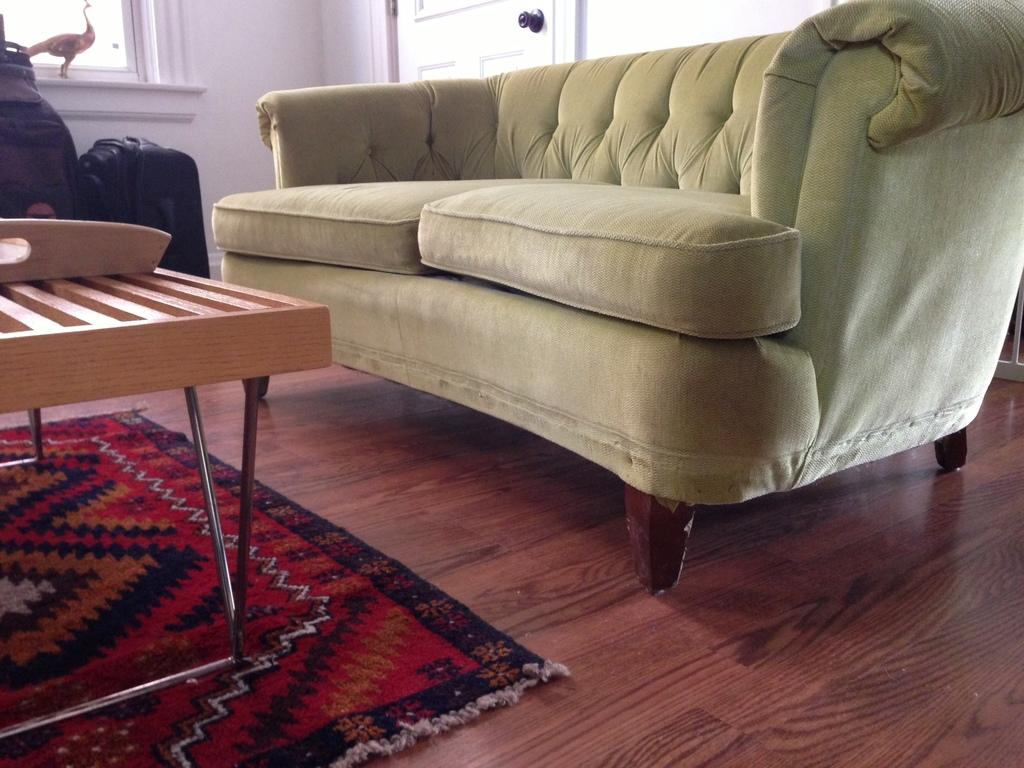What type of furniture is present in the image? There is a sofa in the image. What other piece of furniture can be seen in the image? There is a table in the image. What architectural feature is visible in the image? There is a window in the image. What is located in the background of the image? There is a door in the background of the image. What reason does the bed have for being in the image? There is no bed present in the image. What desire is being fulfilled by the presence of the sofa in the image? The image does not provide information about the desires of the people or the purpose of the sofa. 